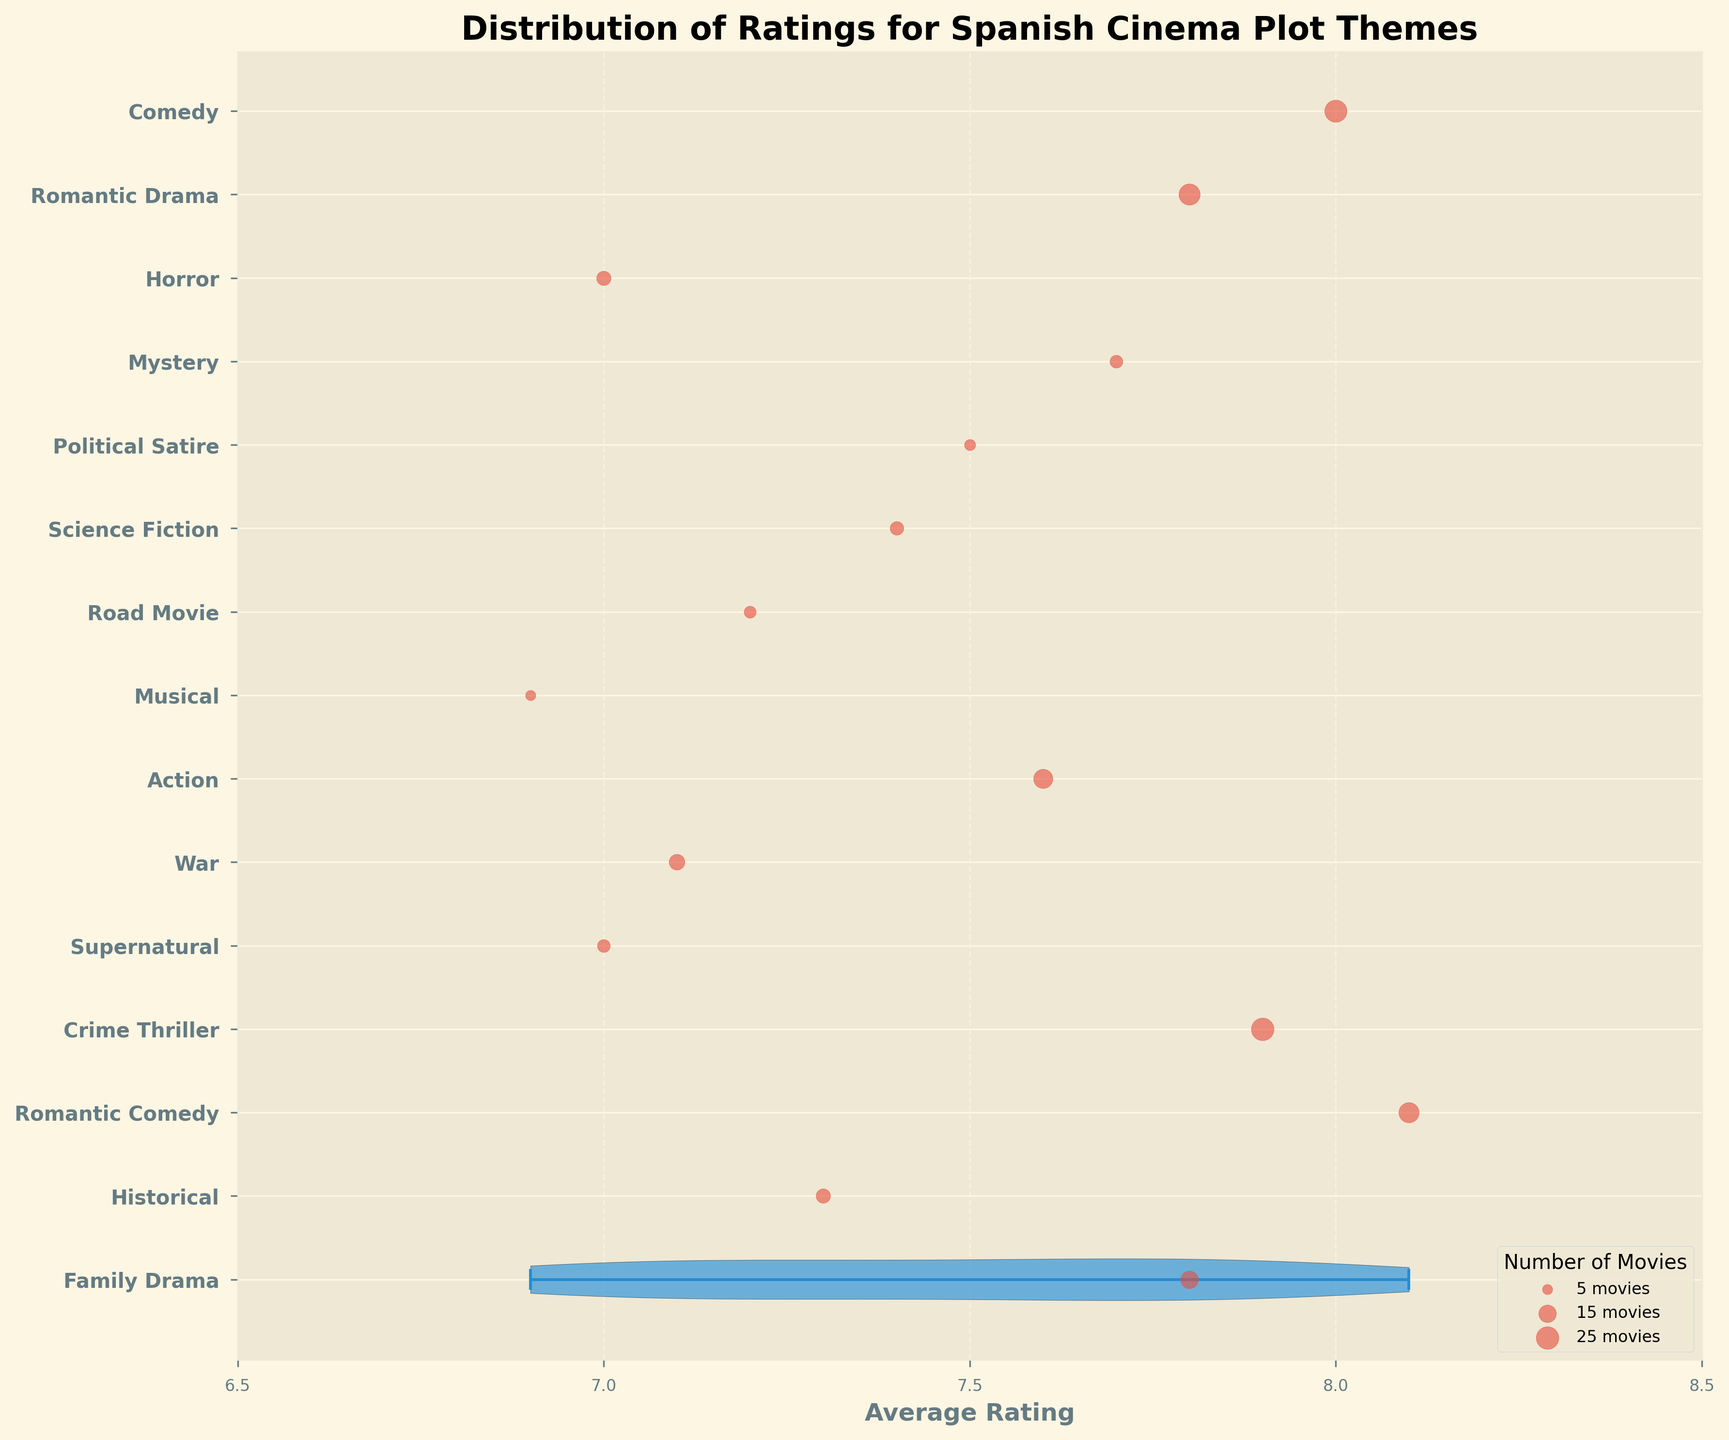What is the title of the plot? The title can be found at the top of the chart, which is usually large and bold to indicate its importance. The provided title reads "Distribution of Ratings for Spanish Cinema Plot Themes".
Answer: Distribution of Ratings for Spanish Cinema Plot Themes Which plot theme has the highest average rating? Look for the theme with the highest position on the x-axis, as the violin plots represent average ratings horizontally. The Romantic Comedy theme is at the highest position on the x-axis.
Answer: Romantic Comedy How many movies are there under the Crime Thriller theme? Number of movies is indicated by the size of the scatter plot points. Look for the size legend in the lower right corner of the plot. The Crime Thriller theme has a large scatter point, corresponding to 25 movies.
Answer: 25 movies What’s the average rating of the Horror theme? Locate the position of the Horror theme on the vertical axis and check its position horizontally against the x-axis for ratings. The average rating for Horror is at the 7.0 mark.
Answer: 7.0 Which theme has the lowest-rated movies on average? Identify the theme with the lowest horizontal position on the x-axis among all the themes. The Musical theme is located at the lowest average rating of 6.9.
Answer: Musical How do the average ratings for Romantic Comedy and Comedy compare? Locate and compare the horizontal positions of these two themes on the x-axis. Romantic Comedy and Comedy are close, with average ratings of 8.1 and 8.0 respectively. Romantic Comedy has a slightly higher rating.
Answer: Romantic Comedy is higher What is the range of average ratings displayed on the x-axis? Check the x-axis ticks to determine the range shown in the plot. The x-axis ranges from 6.5 to 8.5.
Answer: 6.5 to 8.5 If we sum up the number of movies under Family Drama and Historical, what’s the total? Add the number of movies from the Family Drama (15) and Historical (10) themes. 15 + 10 equals 25.
Answer: 25 Which theme in the plot has an average rating closest to 7.5? Find the themes near the 7.5 tick mark on the x-axis. Political Satire is the closest with an average rating of 7.5.
Answer: Political Satire What is a noticeable color representation used in the scatter plots against the violin plots? Look at the color of scatter plot points and violin plots. The scatter points are red, while the violin plots are shaded in blue with a darker outline.
Answer: Red scatter points and blue violin plots 